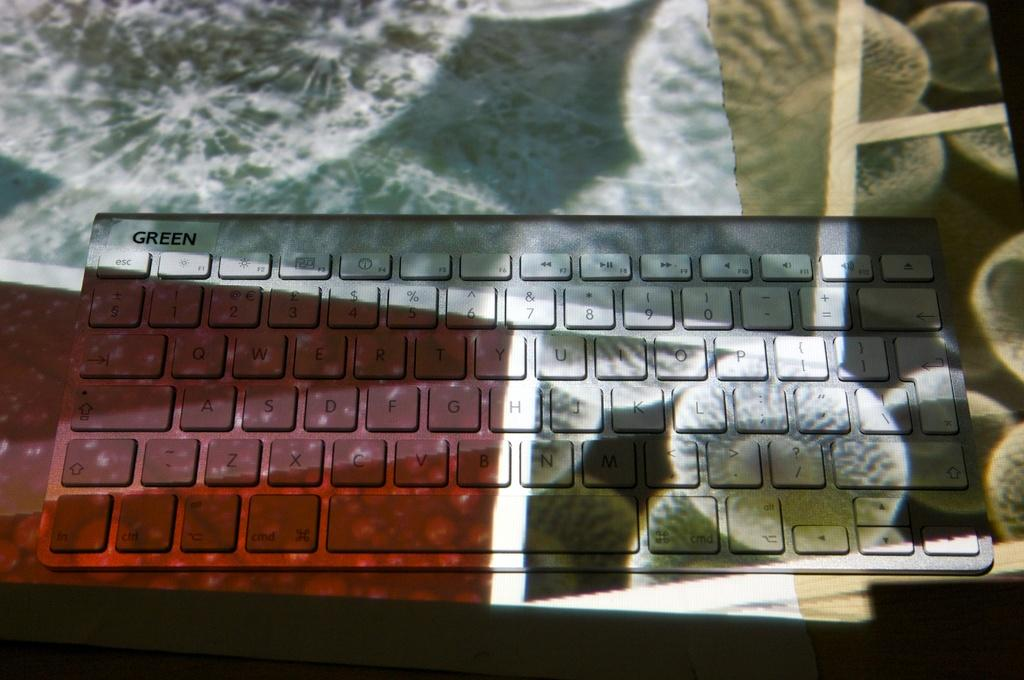What is the main object in the image? There is a keyboard in the image. Where is the keyboard located? The keyboard is on a table. What other items can be seen in the image? There are decorative papers in the image. What type of record can be seen in the image? There is no record or any type of record in the image; it only features a keyboard and decorative papers. 